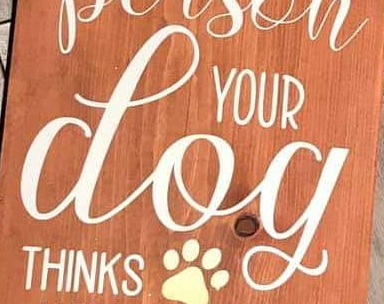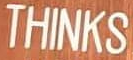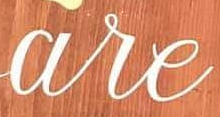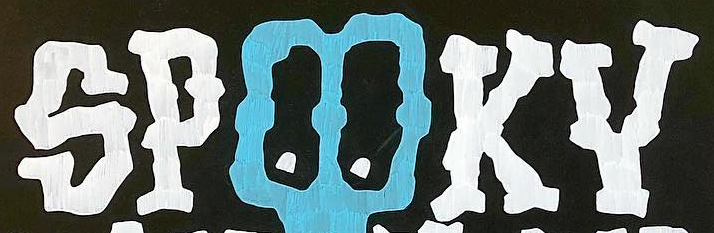What text is displayed in these images sequentially, separated by a semicolon? dog; THINKS; are; SPOOKY 